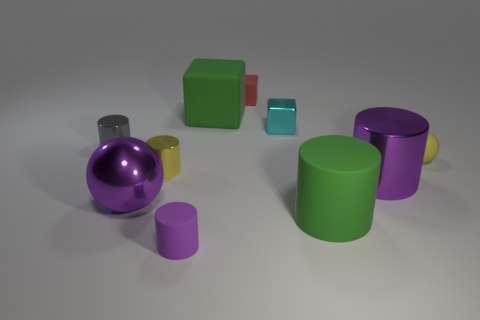How many purple cylinders must be subtracted to get 1 purple cylinders? 1 Subtract all gray cylinders. How many cylinders are left? 4 Subtract all purple rubber cylinders. How many cylinders are left? 4 Subtract 1 cylinders. How many cylinders are left? 4 Subtract all cyan cylinders. Subtract all purple cubes. How many cylinders are left? 5 Subtract all spheres. How many objects are left? 8 Add 9 large rubber blocks. How many large rubber blocks exist? 10 Subtract 0 blue cylinders. How many objects are left? 10 Subtract all large purple things. Subtract all big metal cylinders. How many objects are left? 7 Add 2 tiny cyan objects. How many tiny cyan objects are left? 3 